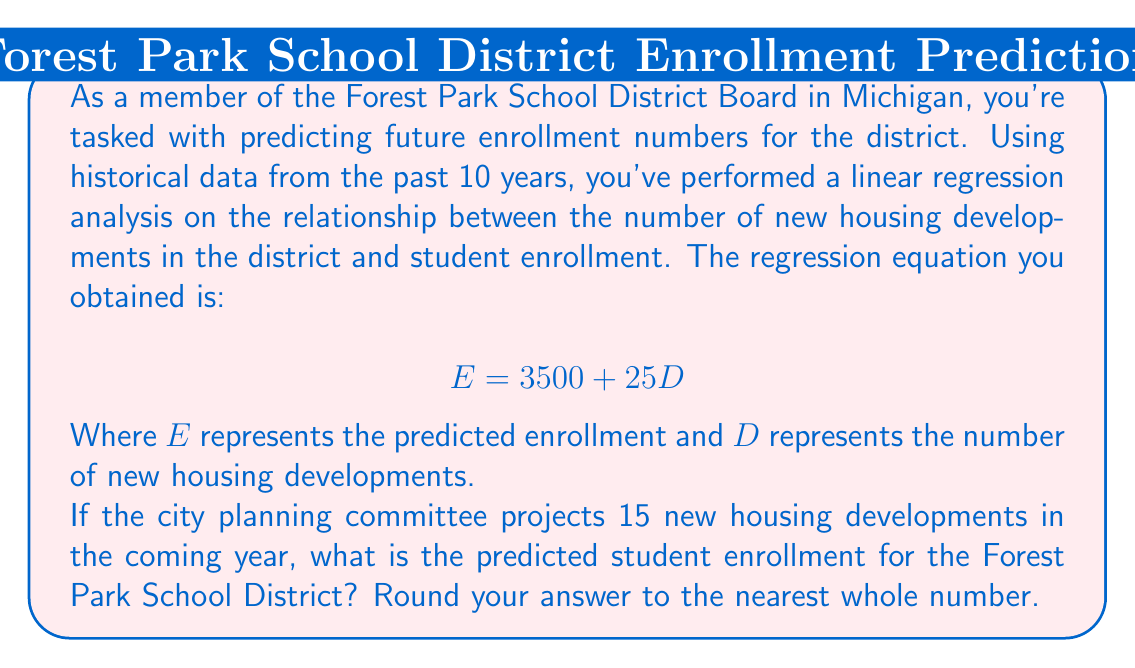Help me with this question. To solve this problem, we'll use the given linear regression equation and substitute the known value for the number of new housing developments (D).

1. The linear regression equation is:
   $$ E = 3500 + 25D $$

2. We're given that there will be 15 new housing developments, so D = 15.

3. Substitute D = 15 into the equation:
   $$ E = 3500 + 25(15) $$

4. Simplify:
   $$ E = 3500 + 375 $$
   $$ E = 3875 $$

5. The question asks to round to the nearest whole number, but 3875 is already a whole number, so no rounding is necessary.

This regression analysis suggests that with 15 new housing developments, we can expect an enrollment of 3,875 students in the Forest Park School District for the coming year.
Answer: 3,875 students 